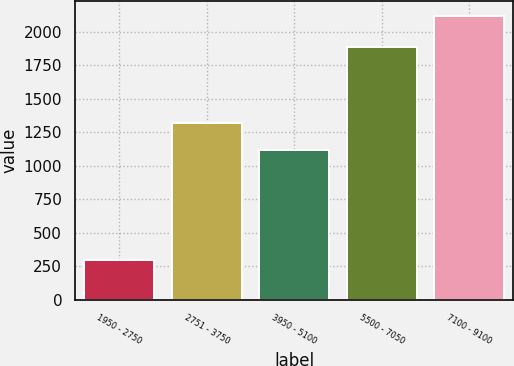Convert chart. <chart><loc_0><loc_0><loc_500><loc_500><bar_chart><fcel>1950 - 2750<fcel>2751 - 3750<fcel>3950 - 5100<fcel>5500 - 7050<fcel>7100 - 9100<nl><fcel>298<fcel>1317<fcel>1115<fcel>1890<fcel>2122<nl></chart> 